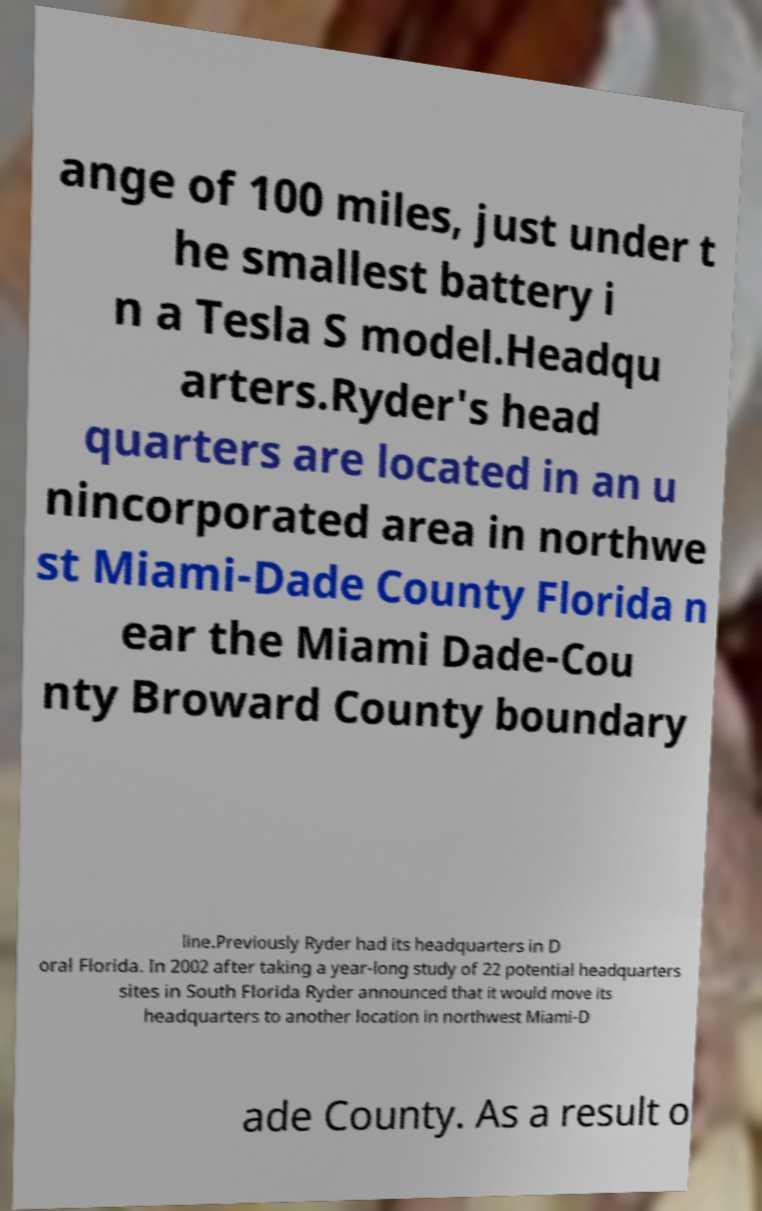Could you assist in decoding the text presented in this image and type it out clearly? ange of 100 miles, just under t he smallest battery i n a Tesla S model.Headqu arters.Ryder's head quarters are located in an u nincorporated area in northwe st Miami-Dade County Florida n ear the Miami Dade-Cou nty Broward County boundary line.Previously Ryder had its headquarters in D oral Florida. In 2002 after taking a year-long study of 22 potential headquarters sites in South Florida Ryder announced that it would move its headquarters to another location in northwest Miami-D ade County. As a result o 